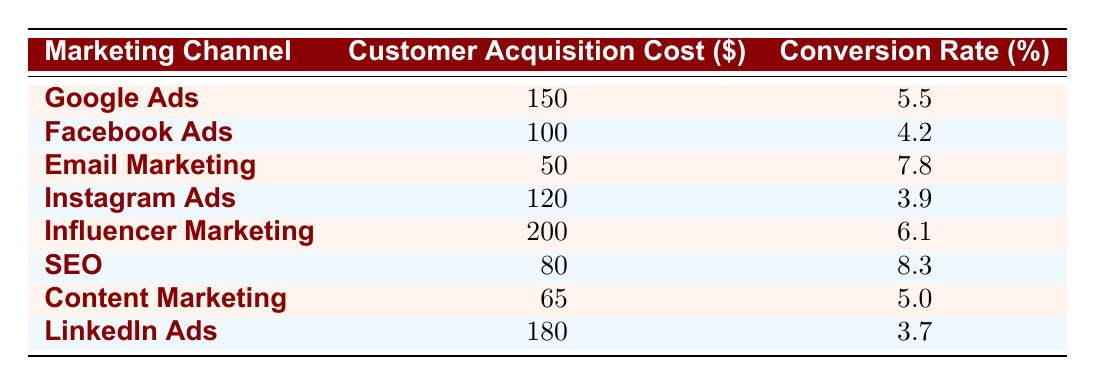What is the customer acquisition cost for Email Marketing? The table lists the customer acquisition cost for Email Marketing as 50.
Answer: 50 Which marketing channel has the highest conversion rate? From the table, the highest conversion rate is listed for SEO at 8.3.
Answer: SEO What is the average customer acquisition cost across all channels? To find the average, sum all customer acquisition costs: (150 + 100 + 50 + 120 + 200 + 80 + 65 + 180) = 945. There are 8 channels, so the average cost is 945/8 = 118.125.
Answer: 118.125 Is the conversion rate for Facebook Ads higher than that for LinkedIn Ads? The table shows Facebook Ads has a conversion rate of 4.2, while LinkedIn Ads has a conversion rate of 3.7. Since 4.2 is greater than 3.7, the statement is true.
Answer: Yes Which marketing channels have a customer acquisition cost below $100? According to the table, the channels with costs below $100 are Email Marketing (50), SEO (80), and Content Marketing (65).
Answer: Email Marketing, SEO, Content Marketing If we sum the conversion rates of Google Ads and Instagram Ads, what do we get? From the table, Google Ads has a conversion rate of 5.5 and Instagram Ads has a rate of 3.9. Their total is 5.5 + 3.9 = 9.4.
Answer: 9.4 Do any marketing channels have a conversion rate below 4%? Reviewing the table, Instagram Ads has a conversion rate of 3.9, which is below 4%. Therefore, the statement is true.
Answer: Yes What is the difference in customer acquisition costs between Influencer Marketing and Facebook Ads? Influencer Marketing costs 200, and Facebook Ads costs 100. The difference is 200 - 100 = 100.
Answer: 100 Which marketing channel provides the best cost-to-conversion rate ratio? To determine this, we calculate the cost-to-conversion rate ratio for each channel. The channel with the lowest ratio (cost divided by conversion rate) is Email Marketing: 50/7.8 = 6.41, which is the best ratio compared to others.
Answer: Email Marketing 